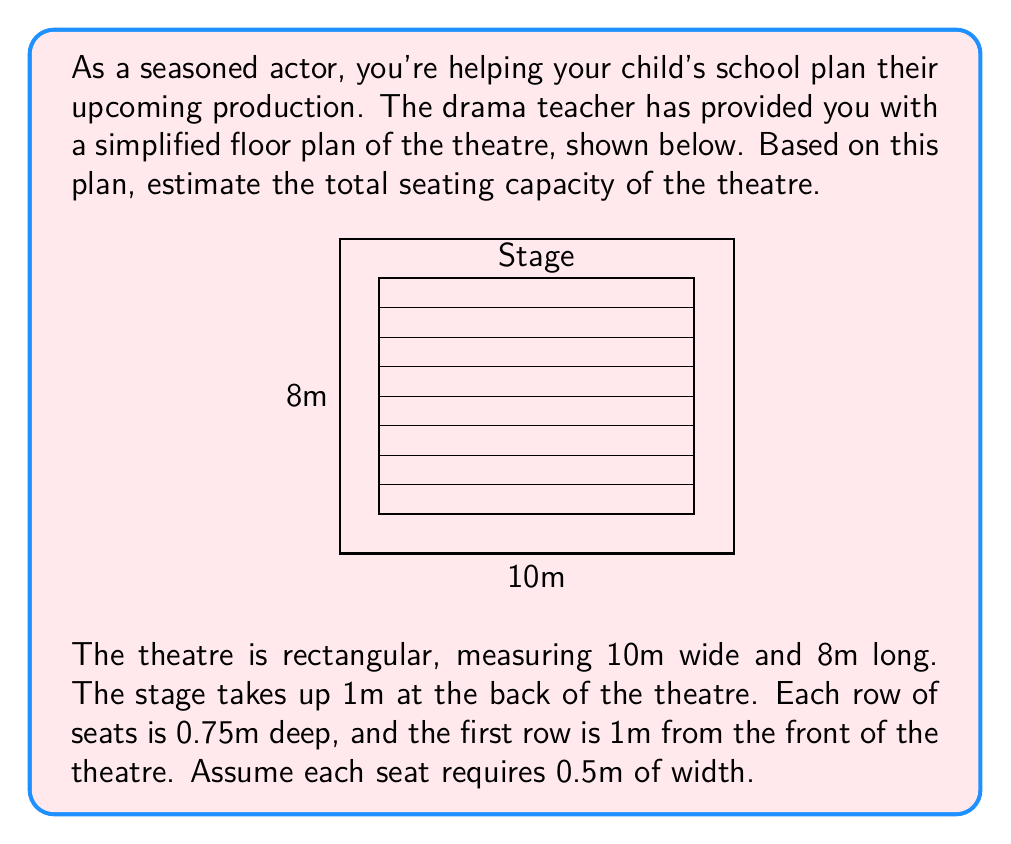Can you answer this question? Let's approach this step-by-step:

1) First, calculate the available length for seating:
   Total length - Stage depth - Front space = $8m - 1m - 1m = 6m$

2) Determine the number of rows:
   Available length ÷ Row depth = $6m \div 0.75m = 8$ rows

3) Calculate the available width for seating:
   Total width - Side aisles = $10m - 2m = 8m$

4) Determine the number of seats per row:
   Available width ÷ Seat width = $8m \div 0.5m = 16$ seats per row

5) Calculate total seating capacity:
   Number of rows × Seats per row = $8 \times 16 = 128$ seats

Therefore, the estimated seating capacity of the theatre is 128 seats.
Answer: 128 seats 